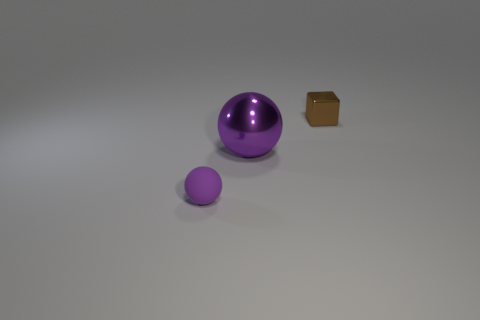Are there the same number of brown things that are left of the matte thing and purple objects that are to the right of the large metal sphere?
Ensure brevity in your answer.  Yes. How many things are brown metal things or big brown cylinders?
Make the answer very short. 1. What is the color of the object that is the same size as the brown cube?
Offer a terse response. Purple. How many things are either balls that are behind the matte thing or spheres that are behind the matte object?
Ensure brevity in your answer.  1. Is the number of small purple objects on the right side of the large metallic sphere the same as the number of rubber spheres?
Offer a terse response. No. There is a shiny block that is on the right side of the small matte sphere; does it have the same size as the purple sphere on the left side of the big thing?
Offer a terse response. Yes. How many other objects are there of the same size as the cube?
Ensure brevity in your answer.  1. Is there a metal thing that is behind the tiny thing that is to the left of the big metal object that is on the right side of the tiny rubber object?
Provide a short and direct response. Yes. Are there any other things that have the same color as the metal cube?
Provide a short and direct response. No. There is a purple thing behind the tiny rubber sphere; what is its size?
Offer a terse response. Large. 